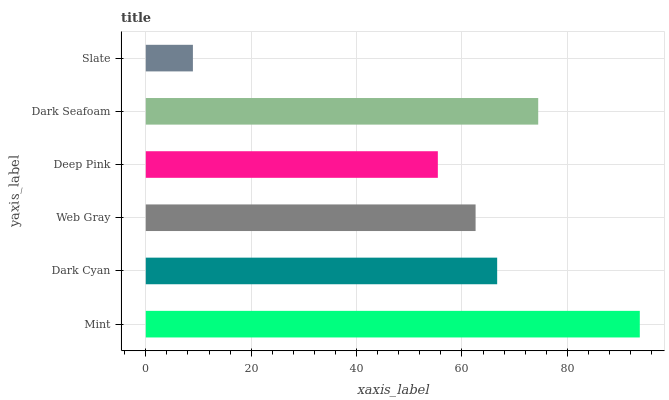Is Slate the minimum?
Answer yes or no. Yes. Is Mint the maximum?
Answer yes or no. Yes. Is Dark Cyan the minimum?
Answer yes or no. No. Is Dark Cyan the maximum?
Answer yes or no. No. Is Mint greater than Dark Cyan?
Answer yes or no. Yes. Is Dark Cyan less than Mint?
Answer yes or no. Yes. Is Dark Cyan greater than Mint?
Answer yes or no. No. Is Mint less than Dark Cyan?
Answer yes or no. No. Is Dark Cyan the high median?
Answer yes or no. Yes. Is Web Gray the low median?
Answer yes or no. Yes. Is Mint the high median?
Answer yes or no. No. Is Mint the low median?
Answer yes or no. No. 